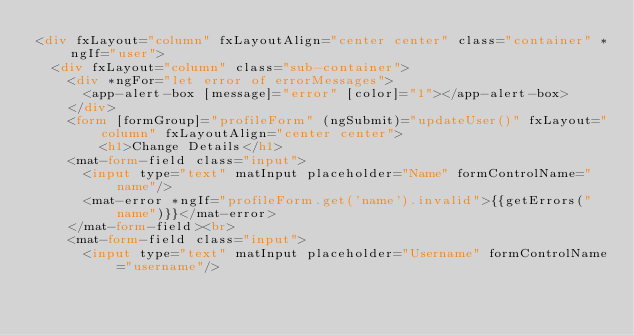<code> <loc_0><loc_0><loc_500><loc_500><_HTML_><div fxLayout="column" fxLayoutAlign="center center" class="container" *ngIf="user">
  <div fxLayout="column" class="sub-container">
    <div *ngFor="let error of errorMessages">
      <app-alert-box [message]="error" [color]="1"></app-alert-box>
    </div>
    <form [formGroup]="profileForm" (ngSubmit)="updateUser()" fxLayout="column" fxLayoutAlign="center center">
        <h1>Change Details</h1>
    <mat-form-field class="input">
      <input type="text" matInput placeholder="Name" formControlName="name"/>
      <mat-error *ngIf="profileForm.get('name').invalid">{{getErrors("name")}}</mat-error>
    </mat-form-field><br>
    <mat-form-field class="input">
      <input type="text" matInput placeholder="Username" formControlName="username"/></code> 